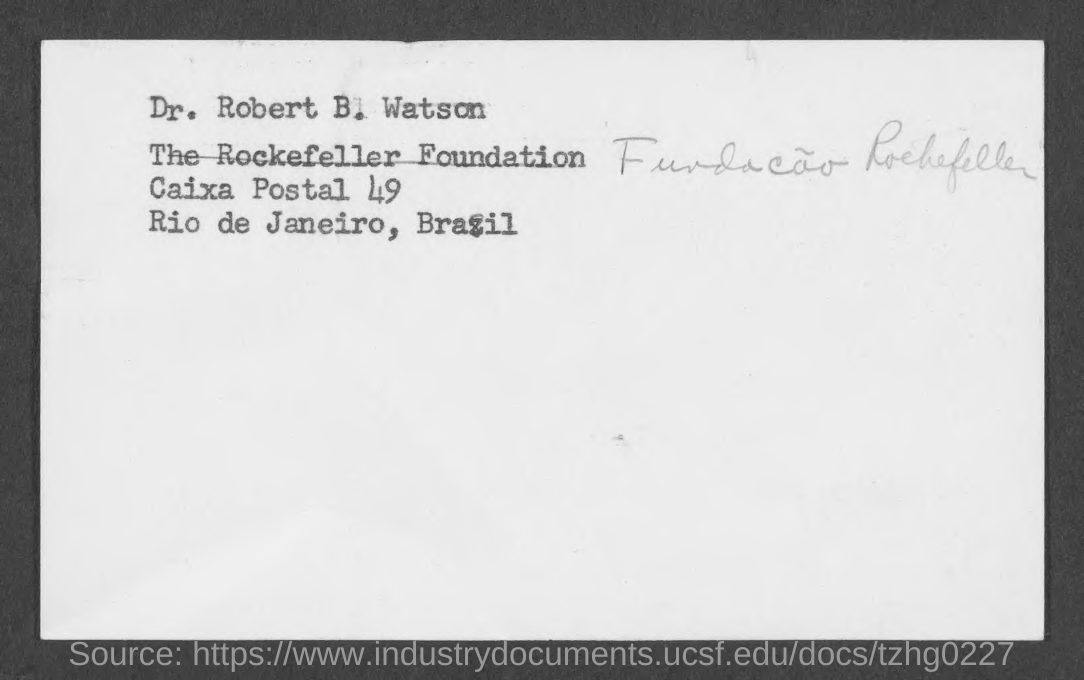Specify some key components in this picture. The postal number mentioned is 49. The address of Dr. Robert B. Watson is given. Dr. Robert B. Watson belongs to Brazil. 